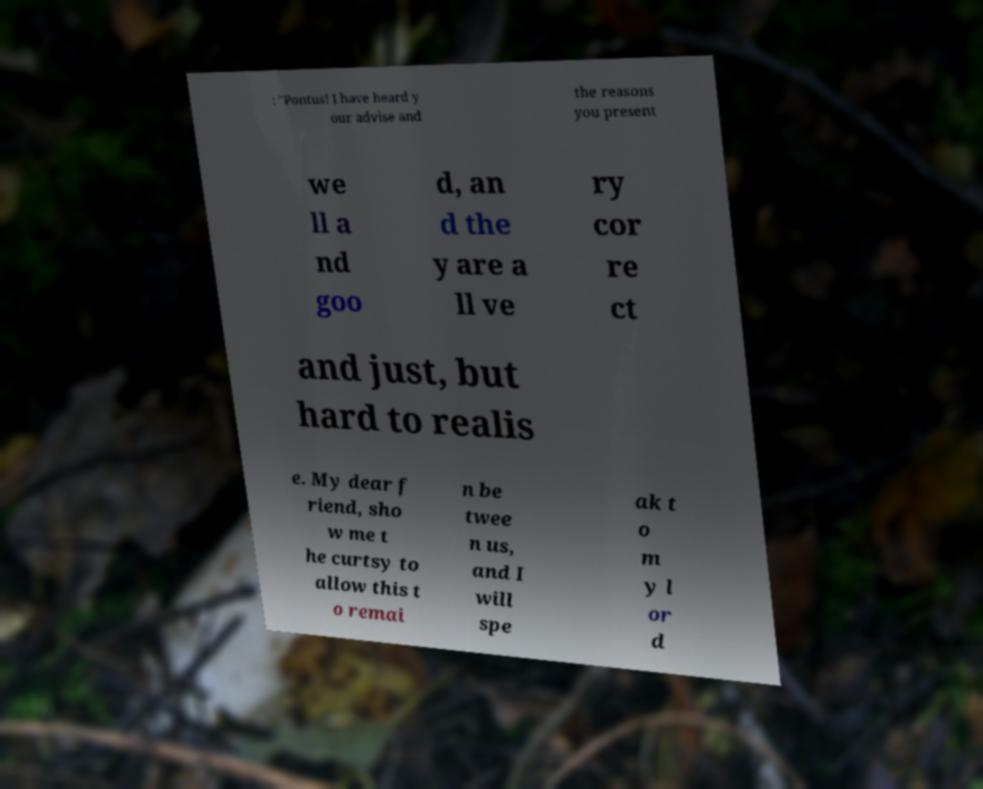Please identify and transcribe the text found in this image. : "Pontus! I have heard y our advise and the reasons you present we ll a nd goo d, an d the y are a ll ve ry cor re ct and just, but hard to realis e. My dear f riend, sho w me t he curtsy to allow this t o remai n be twee n us, and I will spe ak t o m y l or d 